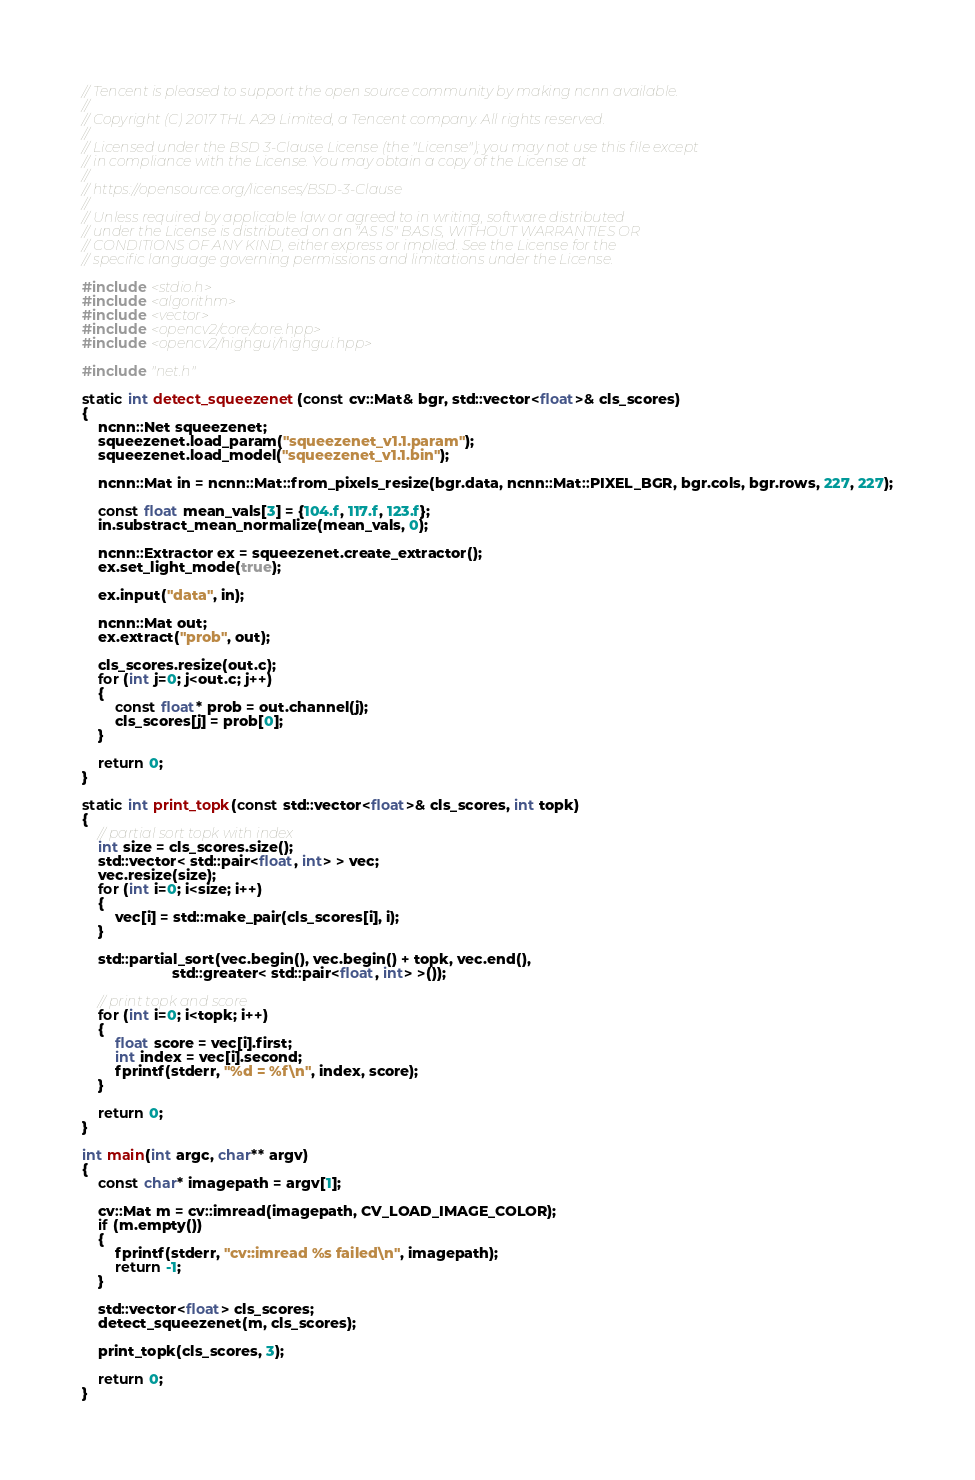<code> <loc_0><loc_0><loc_500><loc_500><_C++_>// Tencent is pleased to support the open source community by making ncnn available.
//
// Copyright (C) 2017 THL A29 Limited, a Tencent company. All rights reserved.
//
// Licensed under the BSD 3-Clause License (the "License"); you may not use this file except
// in compliance with the License. You may obtain a copy of the License at
//
// https://opensource.org/licenses/BSD-3-Clause
//
// Unless required by applicable law or agreed to in writing, software distributed
// under the License is distributed on an "AS IS" BASIS, WITHOUT WARRANTIES OR
// CONDITIONS OF ANY KIND, either express or implied. See the License for the
// specific language governing permissions and limitations under the License.

#include <stdio.h>
#include <algorithm>
#include <vector>
#include <opencv2/core/core.hpp>
#include <opencv2/highgui/highgui.hpp>

#include "net.h"

static int detect_squeezenet(const cv::Mat& bgr, std::vector<float>& cls_scores)
{
    ncnn::Net squeezenet;
    squeezenet.load_param("squeezenet_v1.1.param");
    squeezenet.load_model("squeezenet_v1.1.bin");

    ncnn::Mat in = ncnn::Mat::from_pixels_resize(bgr.data, ncnn::Mat::PIXEL_BGR, bgr.cols, bgr.rows, 227, 227);

    const float mean_vals[3] = {104.f, 117.f, 123.f};
    in.substract_mean_normalize(mean_vals, 0);

    ncnn::Extractor ex = squeezenet.create_extractor();
    ex.set_light_mode(true);

    ex.input("data", in);

    ncnn::Mat out;
    ex.extract("prob", out);

    cls_scores.resize(out.c);
    for (int j=0; j<out.c; j++)
    {
        const float* prob = out.channel(j);
        cls_scores[j] = prob[0];
    }

    return 0;
}

static int print_topk(const std::vector<float>& cls_scores, int topk)
{
    // partial sort topk with index
    int size = cls_scores.size();
    std::vector< std::pair<float, int> > vec;
    vec.resize(size);
    for (int i=0; i<size; i++)
    {
        vec[i] = std::make_pair(cls_scores[i], i);
    }

    std::partial_sort(vec.begin(), vec.begin() + topk, vec.end(),
                      std::greater< std::pair<float, int> >());

    // print topk and score
    for (int i=0; i<topk; i++)
    {
        float score = vec[i].first;
        int index = vec[i].second;
        fprintf(stderr, "%d = %f\n", index, score);
    }

    return 0;
}

int main(int argc, char** argv)
{
    const char* imagepath = argv[1];

    cv::Mat m = cv::imread(imagepath, CV_LOAD_IMAGE_COLOR);
    if (m.empty())
    {
        fprintf(stderr, "cv::imread %s failed\n", imagepath);
        return -1;
    }

    std::vector<float> cls_scores;
    detect_squeezenet(m, cls_scores);

    print_topk(cls_scores, 3);

    return 0;
}

</code> 